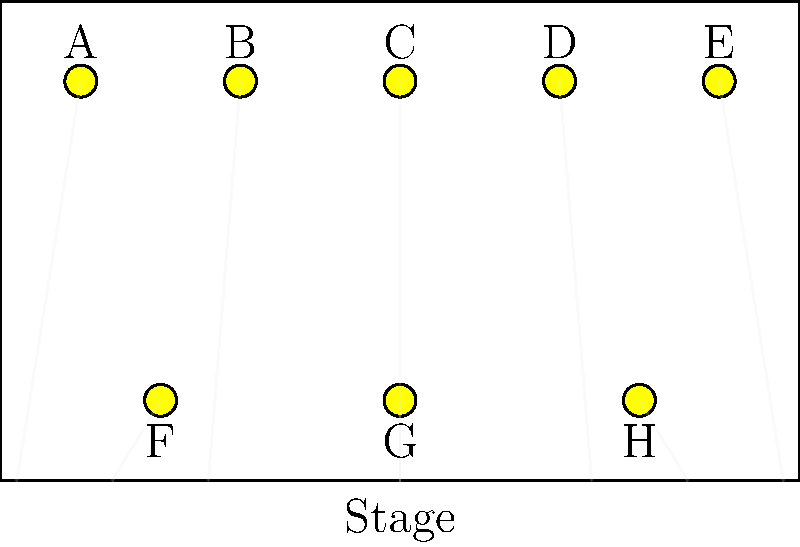In this experimental lighting plot for an avant-garde production, the director wants to create a "golden ratio" effect using light intensity. If the total light output is 1000 lumens, and each fixture's intensity follows the Fibonacci sequence (starting with 1), what is the intensity (in lumens) of fixture C? To solve this problem, we need to follow these steps:

1. Identify the Fibonacci sequence for the 8 fixtures:
   A: 1, B: 1, C: 2, D: 3, E: 5, F: 8, G: 13, H: 21

2. Calculate the sum of the Fibonacci numbers used:
   $1 + 1 + 2 + 3 + 5 + 8 + 13 + 21 = 54$

3. Set up the proportion:
   54 total units : 1000 total lumens
   2 units (for fixture C) : x lumens

4. Solve for x using cross multiplication:
   $54x = 2000$
   $x = \frac{2000}{54} \approx 37.04$

5. Round to the nearest whole number:
   37 lumens

The intensity of fixture C is approximately 37 lumens.
Answer: 37 lumens 